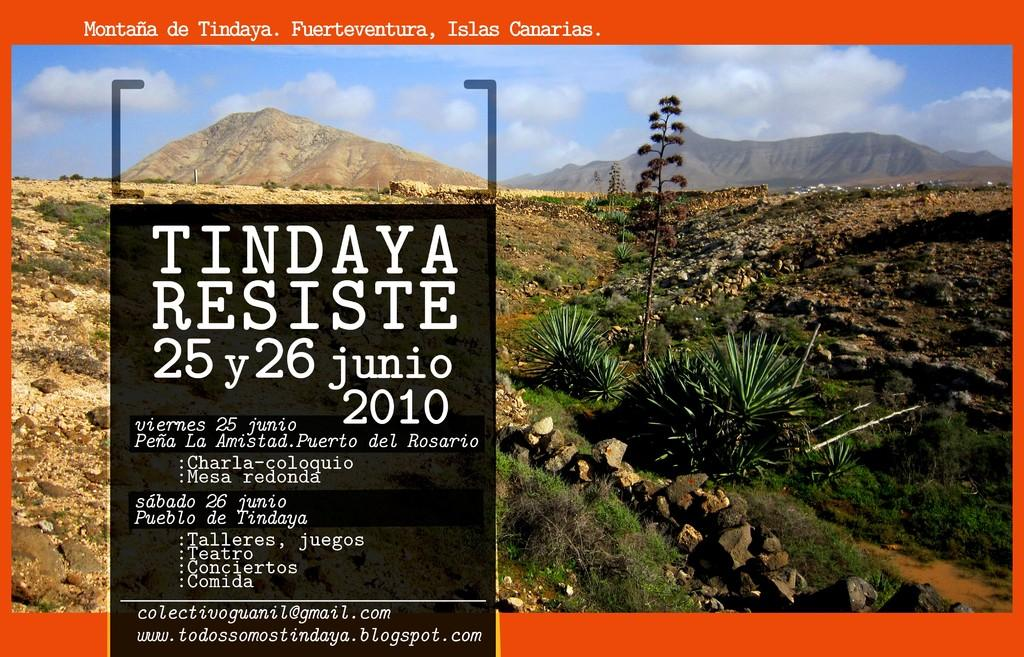What is present in the image that contains both images and text? There is a poster in the image that contains images and text. How many spiders are crawling on the poster in the image? There are no spiders present on the poster in the image. What is the rate of the lift in the image? There is no lift present in the image, so it is not possible to determine the rate. 